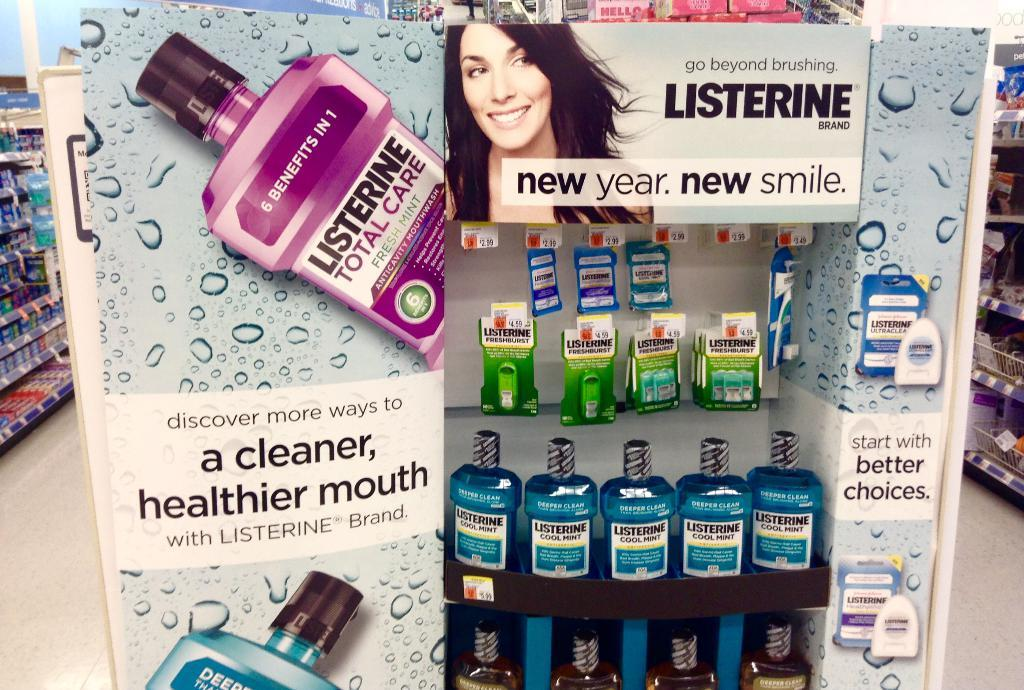<image>
Relay a brief, clear account of the picture shown. A display for Listerine mouth wash in a grocery store. 